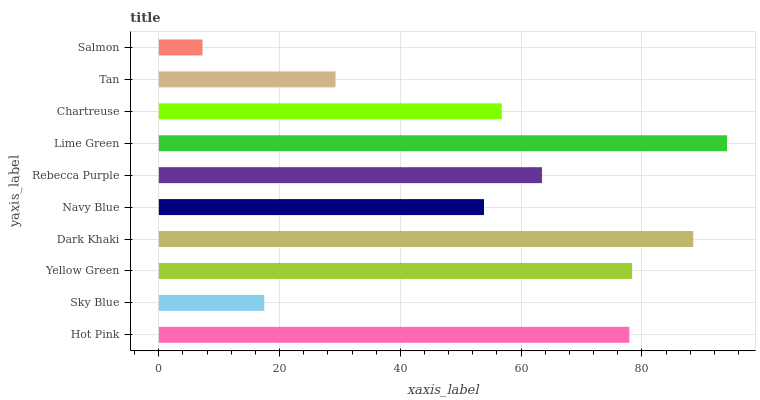Is Salmon the minimum?
Answer yes or no. Yes. Is Lime Green the maximum?
Answer yes or no. Yes. Is Sky Blue the minimum?
Answer yes or no. No. Is Sky Blue the maximum?
Answer yes or no. No. Is Hot Pink greater than Sky Blue?
Answer yes or no. Yes. Is Sky Blue less than Hot Pink?
Answer yes or no. Yes. Is Sky Blue greater than Hot Pink?
Answer yes or no. No. Is Hot Pink less than Sky Blue?
Answer yes or no. No. Is Rebecca Purple the high median?
Answer yes or no. Yes. Is Chartreuse the low median?
Answer yes or no. Yes. Is Lime Green the high median?
Answer yes or no. No. Is Salmon the low median?
Answer yes or no. No. 